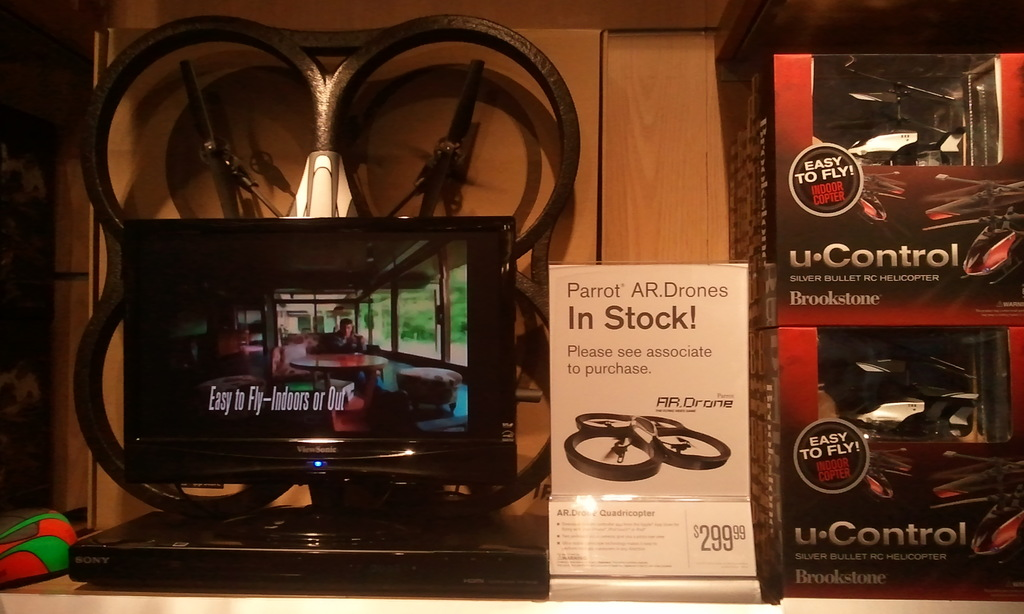What types of drones are shown in the image, and what features do they advertise? The image showcases Parrot AR Drones and a U-Control Silver Bullet RC helicopter. The Parrot drones are advertised with a focus on their availability and a price tag, while the features highlighted include their ease of indoor or outdoor flying. 